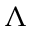Convert formula to latex. <formula><loc_0><loc_0><loc_500><loc_500>\Lambda</formula> 